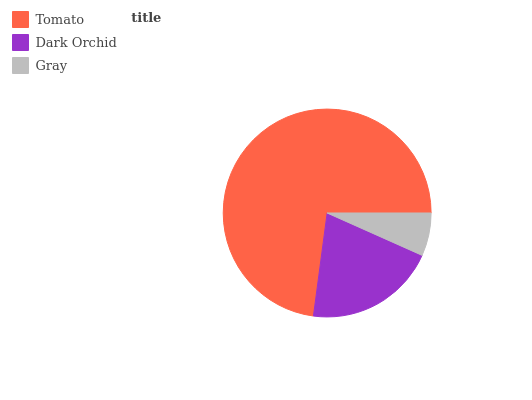Is Gray the minimum?
Answer yes or no. Yes. Is Tomato the maximum?
Answer yes or no. Yes. Is Dark Orchid the minimum?
Answer yes or no. No. Is Dark Orchid the maximum?
Answer yes or no. No. Is Tomato greater than Dark Orchid?
Answer yes or no. Yes. Is Dark Orchid less than Tomato?
Answer yes or no. Yes. Is Dark Orchid greater than Tomato?
Answer yes or no. No. Is Tomato less than Dark Orchid?
Answer yes or no. No. Is Dark Orchid the high median?
Answer yes or no. Yes. Is Dark Orchid the low median?
Answer yes or no. Yes. Is Gray the high median?
Answer yes or no. No. Is Gray the low median?
Answer yes or no. No. 